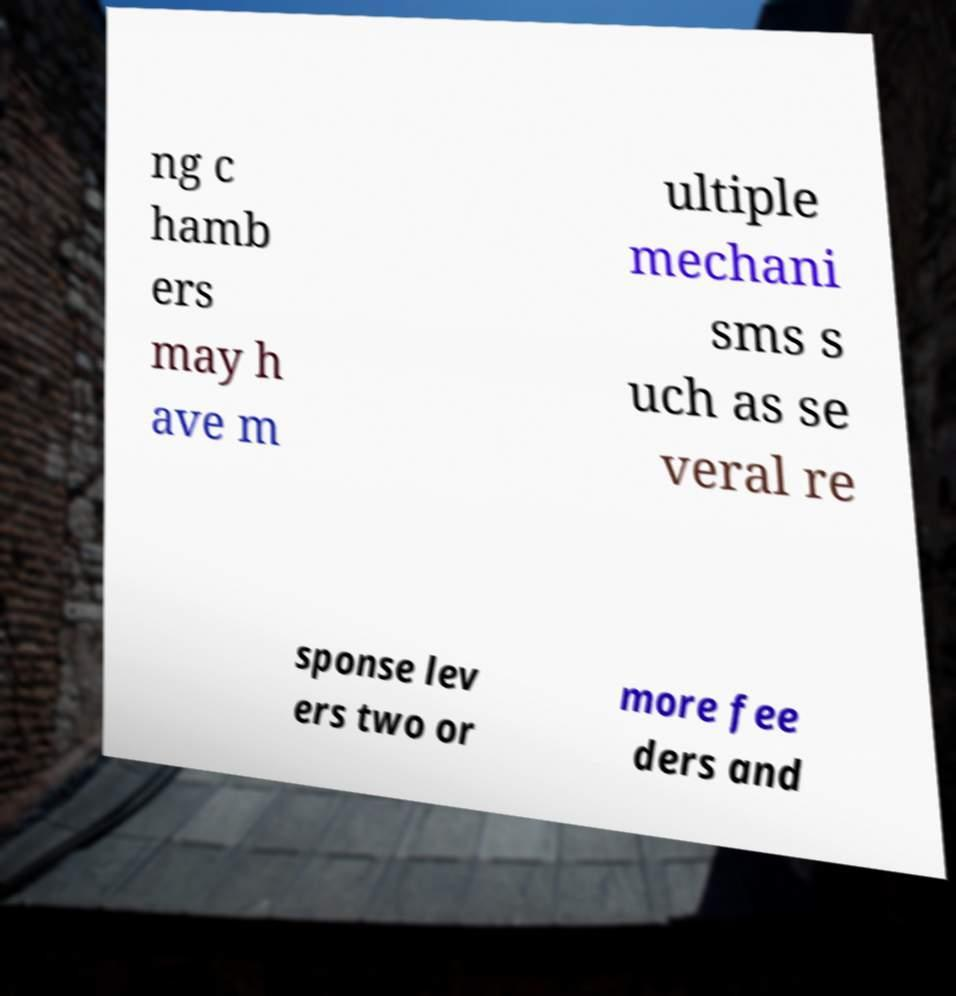Could you assist in decoding the text presented in this image and type it out clearly? ng c hamb ers may h ave m ultiple mechani sms s uch as se veral re sponse lev ers two or more fee ders and 